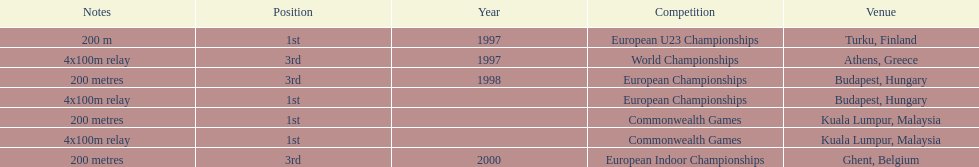How many times was golding in 2nd position? 0. 